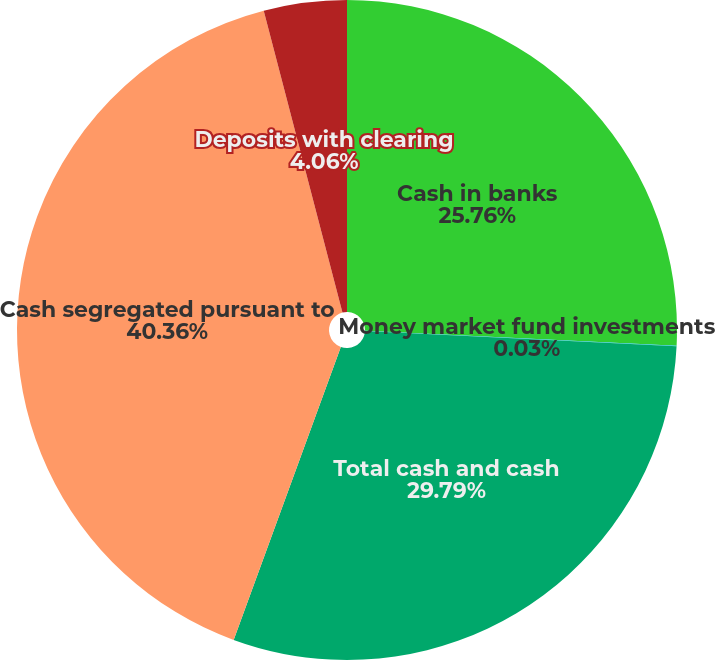<chart> <loc_0><loc_0><loc_500><loc_500><pie_chart><fcel>Cash in banks<fcel>Money market fund investments<fcel>Total cash and cash<fcel>Cash segregated pursuant to<fcel>Deposits with clearing<nl><fcel>25.76%<fcel>0.03%<fcel>29.79%<fcel>40.36%<fcel>4.06%<nl></chart> 